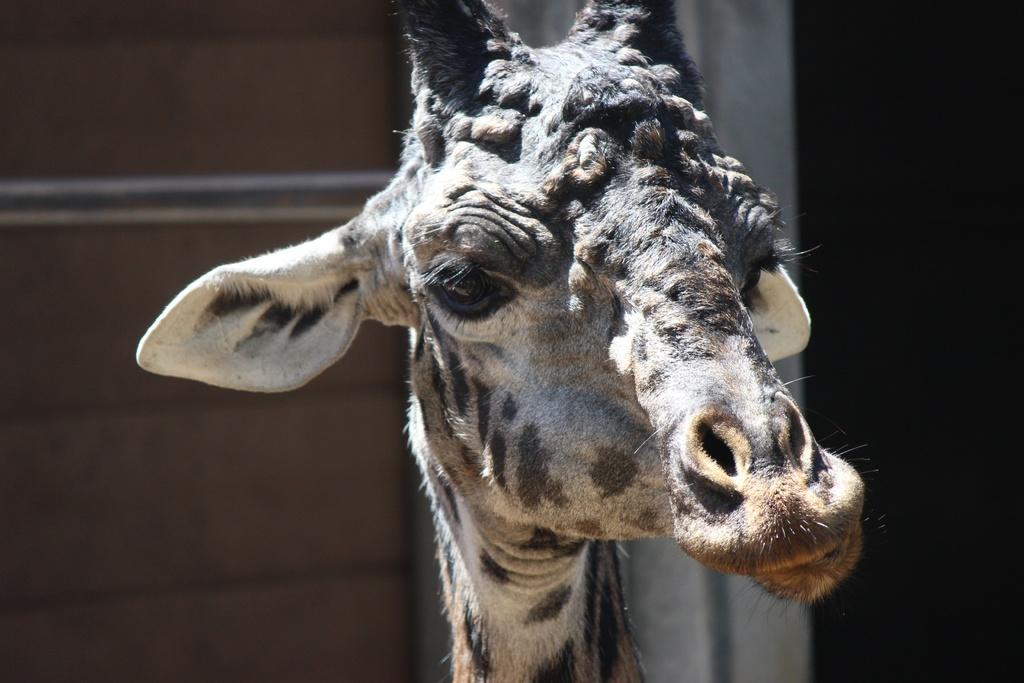Can you describe this image briefly? In the foreground of this picture we can see a giraffe. In the background we can see the metal rod and a wall like object. 